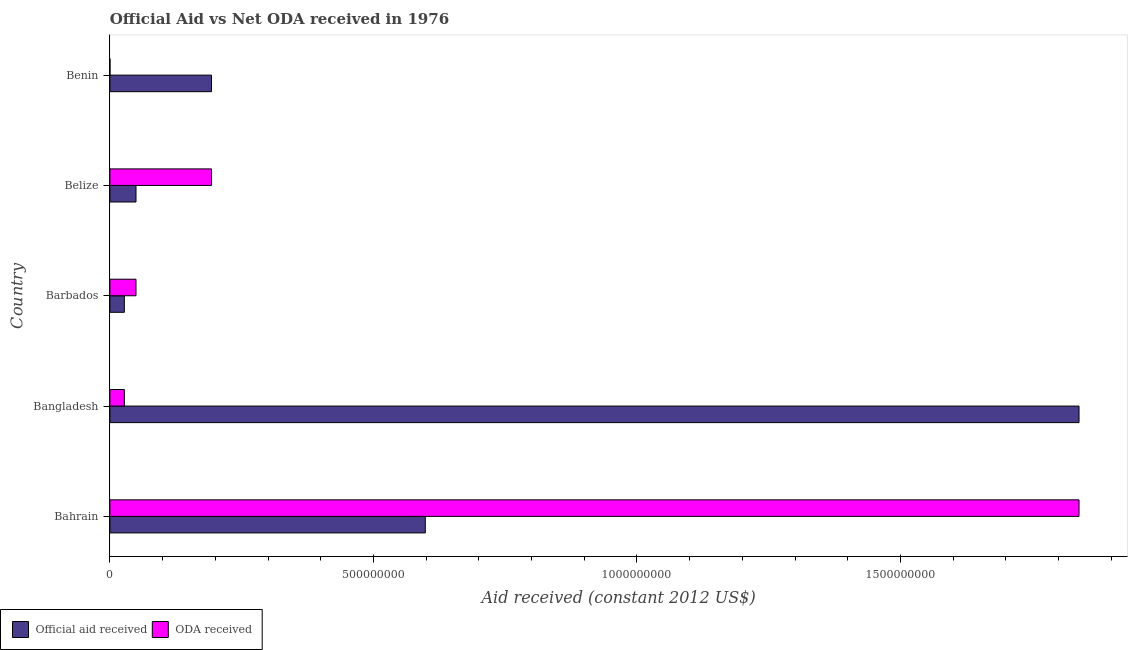Are the number of bars per tick equal to the number of legend labels?
Ensure brevity in your answer.  Yes. Are the number of bars on each tick of the Y-axis equal?
Keep it short and to the point. Yes. How many bars are there on the 4th tick from the top?
Ensure brevity in your answer.  2. What is the official aid received in Benin?
Provide a short and direct response. 1.93e+08. Across all countries, what is the maximum official aid received?
Offer a very short reply. 1.84e+09. Across all countries, what is the minimum official aid received?
Give a very brief answer. 2.74e+07. In which country was the official aid received maximum?
Your answer should be very brief. Bangladesh. In which country was the official aid received minimum?
Your answer should be compact. Barbados. What is the total oda received in the graph?
Keep it short and to the point. 2.11e+09. What is the difference between the oda received in Bangladesh and that in Belize?
Provide a succinct answer. -1.65e+08. What is the difference between the official aid received in Bahrain and the oda received in Barbados?
Make the answer very short. 5.49e+08. What is the average oda received per country?
Give a very brief answer. 4.22e+08. What is the difference between the official aid received and oda received in Benin?
Your answer should be compact. 1.93e+08. In how many countries, is the oda received greater than 1000000000 US$?
Provide a short and direct response. 1. What is the ratio of the official aid received in Bahrain to that in Bangladesh?
Offer a terse response. 0.33. Is the oda received in Belize less than that in Benin?
Provide a short and direct response. No. Is the difference between the official aid received in Bahrain and Bangladesh greater than the difference between the oda received in Bahrain and Bangladesh?
Provide a short and direct response. No. What is the difference between the highest and the second highest official aid received?
Your response must be concise. 1.24e+09. What is the difference between the highest and the lowest oda received?
Give a very brief answer. 1.84e+09. In how many countries, is the oda received greater than the average oda received taken over all countries?
Give a very brief answer. 1. Is the sum of the official aid received in Barbados and Benin greater than the maximum oda received across all countries?
Your answer should be very brief. No. What does the 2nd bar from the top in Bahrain represents?
Your response must be concise. Official aid received. What does the 2nd bar from the bottom in Bangladesh represents?
Your response must be concise. ODA received. How many bars are there?
Give a very brief answer. 10. How many countries are there in the graph?
Offer a very short reply. 5. What is the difference between two consecutive major ticks on the X-axis?
Ensure brevity in your answer.  5.00e+08. Does the graph contain any zero values?
Your response must be concise. No. Does the graph contain grids?
Provide a short and direct response. No. Where does the legend appear in the graph?
Give a very brief answer. Bottom left. What is the title of the graph?
Ensure brevity in your answer.  Official Aid vs Net ODA received in 1976 . Does "Commercial bank branches" appear as one of the legend labels in the graph?
Your answer should be very brief. No. What is the label or title of the X-axis?
Provide a short and direct response. Aid received (constant 2012 US$). What is the Aid received (constant 2012 US$) of Official aid received in Bahrain?
Make the answer very short. 5.98e+08. What is the Aid received (constant 2012 US$) of ODA received in Bahrain?
Your response must be concise. 1.84e+09. What is the Aid received (constant 2012 US$) of Official aid received in Bangladesh?
Provide a short and direct response. 1.84e+09. What is the Aid received (constant 2012 US$) in ODA received in Bangladesh?
Your answer should be compact. 2.74e+07. What is the Aid received (constant 2012 US$) of Official aid received in Barbados?
Offer a terse response. 2.74e+07. What is the Aid received (constant 2012 US$) in ODA received in Barbados?
Keep it short and to the point. 4.96e+07. What is the Aid received (constant 2012 US$) in Official aid received in Belize?
Your answer should be very brief. 4.96e+07. What is the Aid received (constant 2012 US$) of ODA received in Belize?
Your answer should be very brief. 1.93e+08. What is the Aid received (constant 2012 US$) of Official aid received in Benin?
Provide a short and direct response. 1.93e+08. What is the Aid received (constant 2012 US$) of ODA received in Benin?
Provide a succinct answer. 1.40e+05. Across all countries, what is the maximum Aid received (constant 2012 US$) in Official aid received?
Keep it short and to the point. 1.84e+09. Across all countries, what is the maximum Aid received (constant 2012 US$) in ODA received?
Make the answer very short. 1.84e+09. Across all countries, what is the minimum Aid received (constant 2012 US$) of Official aid received?
Your response must be concise. 2.74e+07. Across all countries, what is the minimum Aid received (constant 2012 US$) of ODA received?
Provide a short and direct response. 1.40e+05. What is the total Aid received (constant 2012 US$) of Official aid received in the graph?
Ensure brevity in your answer.  2.71e+09. What is the total Aid received (constant 2012 US$) in ODA received in the graph?
Ensure brevity in your answer.  2.11e+09. What is the difference between the Aid received (constant 2012 US$) of Official aid received in Bahrain and that in Bangladesh?
Keep it short and to the point. -1.24e+09. What is the difference between the Aid received (constant 2012 US$) in ODA received in Bahrain and that in Bangladesh?
Keep it short and to the point. 1.81e+09. What is the difference between the Aid received (constant 2012 US$) of Official aid received in Bahrain and that in Barbados?
Keep it short and to the point. 5.71e+08. What is the difference between the Aid received (constant 2012 US$) of ODA received in Bahrain and that in Barbados?
Ensure brevity in your answer.  1.79e+09. What is the difference between the Aid received (constant 2012 US$) in Official aid received in Bahrain and that in Belize?
Keep it short and to the point. 5.49e+08. What is the difference between the Aid received (constant 2012 US$) in ODA received in Bahrain and that in Belize?
Offer a terse response. 1.65e+09. What is the difference between the Aid received (constant 2012 US$) in Official aid received in Bahrain and that in Benin?
Offer a terse response. 4.06e+08. What is the difference between the Aid received (constant 2012 US$) of ODA received in Bahrain and that in Benin?
Make the answer very short. 1.84e+09. What is the difference between the Aid received (constant 2012 US$) in Official aid received in Bangladesh and that in Barbados?
Provide a short and direct response. 1.81e+09. What is the difference between the Aid received (constant 2012 US$) in ODA received in Bangladesh and that in Barbados?
Ensure brevity in your answer.  -2.21e+07. What is the difference between the Aid received (constant 2012 US$) of Official aid received in Bangladesh and that in Belize?
Provide a short and direct response. 1.79e+09. What is the difference between the Aid received (constant 2012 US$) in ODA received in Bangladesh and that in Belize?
Your response must be concise. -1.65e+08. What is the difference between the Aid received (constant 2012 US$) of Official aid received in Bangladesh and that in Benin?
Offer a terse response. 1.65e+09. What is the difference between the Aid received (constant 2012 US$) in ODA received in Bangladesh and that in Benin?
Provide a succinct answer. 2.73e+07. What is the difference between the Aid received (constant 2012 US$) of Official aid received in Barbados and that in Belize?
Offer a terse response. -2.21e+07. What is the difference between the Aid received (constant 2012 US$) of ODA received in Barbados and that in Belize?
Your answer should be compact. -1.43e+08. What is the difference between the Aid received (constant 2012 US$) of Official aid received in Barbados and that in Benin?
Your answer should be very brief. -1.65e+08. What is the difference between the Aid received (constant 2012 US$) in ODA received in Barbados and that in Benin?
Your response must be concise. 4.94e+07. What is the difference between the Aid received (constant 2012 US$) of Official aid received in Belize and that in Benin?
Your answer should be very brief. -1.43e+08. What is the difference between the Aid received (constant 2012 US$) of ODA received in Belize and that in Benin?
Offer a very short reply. 1.93e+08. What is the difference between the Aid received (constant 2012 US$) of Official aid received in Bahrain and the Aid received (constant 2012 US$) of ODA received in Bangladesh?
Offer a very short reply. 5.71e+08. What is the difference between the Aid received (constant 2012 US$) of Official aid received in Bahrain and the Aid received (constant 2012 US$) of ODA received in Barbados?
Keep it short and to the point. 5.49e+08. What is the difference between the Aid received (constant 2012 US$) in Official aid received in Bahrain and the Aid received (constant 2012 US$) in ODA received in Belize?
Offer a terse response. 4.06e+08. What is the difference between the Aid received (constant 2012 US$) in Official aid received in Bahrain and the Aid received (constant 2012 US$) in ODA received in Benin?
Keep it short and to the point. 5.98e+08. What is the difference between the Aid received (constant 2012 US$) of Official aid received in Bangladesh and the Aid received (constant 2012 US$) of ODA received in Barbados?
Your response must be concise. 1.79e+09. What is the difference between the Aid received (constant 2012 US$) of Official aid received in Bangladesh and the Aid received (constant 2012 US$) of ODA received in Belize?
Provide a succinct answer. 1.65e+09. What is the difference between the Aid received (constant 2012 US$) in Official aid received in Bangladesh and the Aid received (constant 2012 US$) in ODA received in Benin?
Ensure brevity in your answer.  1.84e+09. What is the difference between the Aid received (constant 2012 US$) of Official aid received in Barbados and the Aid received (constant 2012 US$) of ODA received in Belize?
Offer a very short reply. -1.65e+08. What is the difference between the Aid received (constant 2012 US$) in Official aid received in Barbados and the Aid received (constant 2012 US$) in ODA received in Benin?
Your answer should be compact. 2.73e+07. What is the difference between the Aid received (constant 2012 US$) in Official aid received in Belize and the Aid received (constant 2012 US$) in ODA received in Benin?
Your answer should be compact. 4.94e+07. What is the average Aid received (constant 2012 US$) of Official aid received per country?
Make the answer very short. 5.41e+08. What is the average Aid received (constant 2012 US$) in ODA received per country?
Provide a succinct answer. 4.22e+08. What is the difference between the Aid received (constant 2012 US$) of Official aid received and Aid received (constant 2012 US$) of ODA received in Bahrain?
Your answer should be very brief. -1.24e+09. What is the difference between the Aid received (constant 2012 US$) of Official aid received and Aid received (constant 2012 US$) of ODA received in Bangladesh?
Give a very brief answer. 1.81e+09. What is the difference between the Aid received (constant 2012 US$) of Official aid received and Aid received (constant 2012 US$) of ODA received in Barbados?
Make the answer very short. -2.21e+07. What is the difference between the Aid received (constant 2012 US$) in Official aid received and Aid received (constant 2012 US$) in ODA received in Belize?
Provide a short and direct response. -1.43e+08. What is the difference between the Aid received (constant 2012 US$) in Official aid received and Aid received (constant 2012 US$) in ODA received in Benin?
Offer a terse response. 1.93e+08. What is the ratio of the Aid received (constant 2012 US$) of Official aid received in Bahrain to that in Bangladesh?
Keep it short and to the point. 0.33. What is the ratio of the Aid received (constant 2012 US$) in ODA received in Bahrain to that in Bangladesh?
Your response must be concise. 67.09. What is the ratio of the Aid received (constant 2012 US$) in Official aid received in Bahrain to that in Barbados?
Keep it short and to the point. 21.83. What is the ratio of the Aid received (constant 2012 US$) of ODA received in Bahrain to that in Barbados?
Offer a very short reply. 37.11. What is the ratio of the Aid received (constant 2012 US$) in Official aid received in Bahrain to that in Belize?
Your response must be concise. 12.08. What is the ratio of the Aid received (constant 2012 US$) of ODA received in Bahrain to that in Belize?
Keep it short and to the point. 9.54. What is the ratio of the Aid received (constant 2012 US$) in Official aid received in Bahrain to that in Benin?
Offer a terse response. 3.1. What is the ratio of the Aid received (constant 2012 US$) of ODA received in Bahrain to that in Benin?
Keep it short and to the point. 1.31e+04. What is the ratio of the Aid received (constant 2012 US$) in Official aid received in Bangladesh to that in Barbados?
Offer a terse response. 67.09. What is the ratio of the Aid received (constant 2012 US$) in ODA received in Bangladesh to that in Barbados?
Your response must be concise. 0.55. What is the ratio of the Aid received (constant 2012 US$) in Official aid received in Bangladesh to that in Belize?
Your answer should be compact. 37.11. What is the ratio of the Aid received (constant 2012 US$) in ODA received in Bangladesh to that in Belize?
Provide a succinct answer. 0.14. What is the ratio of the Aid received (constant 2012 US$) in Official aid received in Bangladesh to that in Benin?
Keep it short and to the point. 9.54. What is the ratio of the Aid received (constant 2012 US$) of ODA received in Bangladesh to that in Benin?
Your answer should be very brief. 195.79. What is the ratio of the Aid received (constant 2012 US$) of Official aid received in Barbados to that in Belize?
Make the answer very short. 0.55. What is the ratio of the Aid received (constant 2012 US$) of ODA received in Barbados to that in Belize?
Offer a terse response. 0.26. What is the ratio of the Aid received (constant 2012 US$) in Official aid received in Barbados to that in Benin?
Offer a terse response. 0.14. What is the ratio of the Aid received (constant 2012 US$) of ODA received in Barbados to that in Benin?
Provide a short and direct response. 353.93. What is the ratio of the Aid received (constant 2012 US$) in Official aid received in Belize to that in Benin?
Provide a succinct answer. 0.26. What is the ratio of the Aid received (constant 2012 US$) of ODA received in Belize to that in Benin?
Provide a succinct answer. 1377.43. What is the difference between the highest and the second highest Aid received (constant 2012 US$) in Official aid received?
Provide a short and direct response. 1.24e+09. What is the difference between the highest and the second highest Aid received (constant 2012 US$) of ODA received?
Keep it short and to the point. 1.65e+09. What is the difference between the highest and the lowest Aid received (constant 2012 US$) of Official aid received?
Make the answer very short. 1.81e+09. What is the difference between the highest and the lowest Aid received (constant 2012 US$) in ODA received?
Provide a succinct answer. 1.84e+09. 